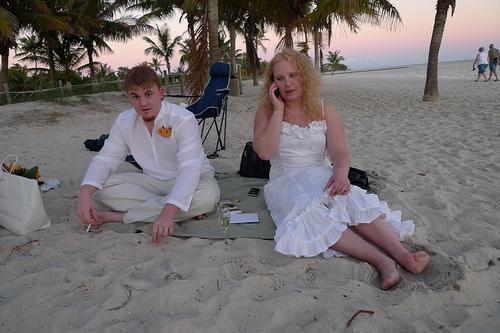How many people are sitting on the beach?
Give a very brief answer. 2. How many people are visible?
Give a very brief answer. 2. How many airplane lights are red?
Give a very brief answer. 0. 